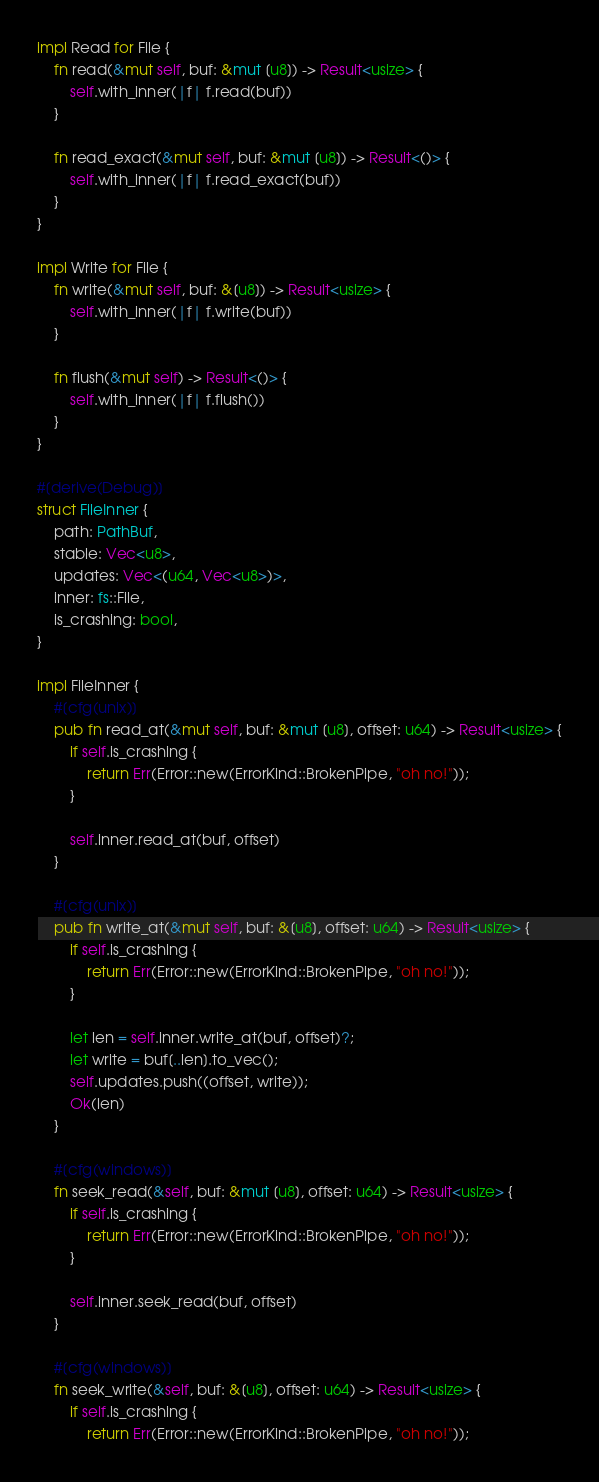Convert code to text. <code><loc_0><loc_0><loc_500><loc_500><_Rust_>impl Read for File {
    fn read(&mut self, buf: &mut [u8]) -> Result<usize> {
        self.with_inner(|f| f.read(buf))
    }

    fn read_exact(&mut self, buf: &mut [u8]) -> Result<()> {
        self.with_inner(|f| f.read_exact(buf))
    }
}

impl Write for File {
    fn write(&mut self, buf: &[u8]) -> Result<usize> {
        self.with_inner(|f| f.write(buf))
    }

    fn flush(&mut self) -> Result<()> {
        self.with_inner(|f| f.flush())
    }
}

#[derive(Debug)]
struct FileInner {
    path: PathBuf,
    stable: Vec<u8>,
    updates: Vec<(u64, Vec<u8>)>,
    inner: fs::File,
    is_crashing: bool,
}

impl FileInner {
    #[cfg(unix)]
    pub fn read_at(&mut self, buf: &mut [u8], offset: u64) -> Result<usize> {
        if self.is_crashing {
            return Err(Error::new(ErrorKind::BrokenPipe, "oh no!"));
        }

        self.inner.read_at(buf, offset)
    }

    #[cfg(unix)]
    pub fn write_at(&mut self, buf: &[u8], offset: u64) -> Result<usize> {
        if self.is_crashing {
            return Err(Error::new(ErrorKind::BrokenPipe, "oh no!"));
        }

        let len = self.inner.write_at(buf, offset)?;
        let write = buf[..len].to_vec();
        self.updates.push((offset, write));
        Ok(len)
    }

    #[cfg(windows)]
    fn seek_read(&self, buf: &mut [u8], offset: u64) -> Result<usize> {
        if self.is_crashing {
            return Err(Error::new(ErrorKind::BrokenPipe, "oh no!"));
        }

        self.inner.seek_read(buf, offset)
    }

    #[cfg(windows)]
    fn seek_write(&self, buf: &[u8], offset: u64) -> Result<usize> {
        if self.is_crashing {
            return Err(Error::new(ErrorKind::BrokenPipe, "oh no!"));</code> 